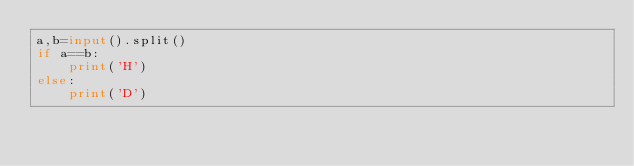Convert code to text. <code><loc_0><loc_0><loc_500><loc_500><_Python_>a,b=input().split()
if a==b:
    print('H')
else:
    print('D')</code> 